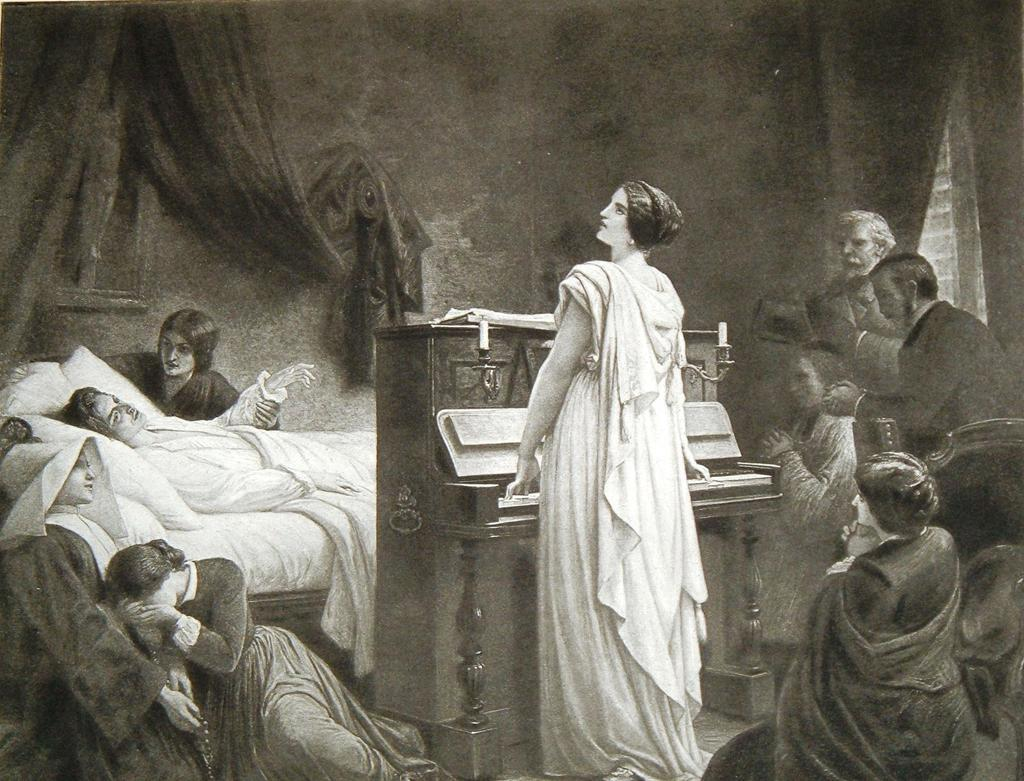What is the color scheme of the image? The image is black and white. Who is the main subject in the image? There is a woman in the image. What is the woman doing in the image? The woman is playing the piano. What else can be seen in the image besides the woman? There is a person laying on a bed in the image. What is the emotional state of the people in the image? There are people crying on either side of the image. What type of exchange is taking place between the woman and the person on the bed? There is no exchange taking place between the woman and the person on the bed in the image. What is the source of attraction in the image? There is no specific source of attraction mentioned or depicted in the image. 